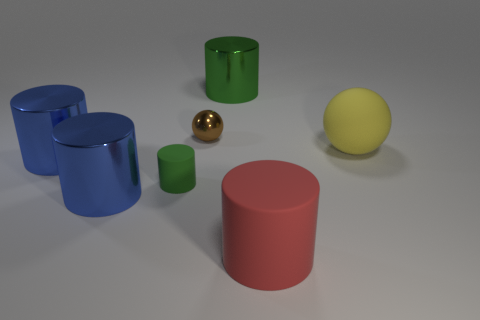The big object that is the same shape as the small brown object is what color?
Ensure brevity in your answer.  Yellow. Are there the same number of big green objects and yellow metallic blocks?
Make the answer very short. No. How many tiny green things are the same shape as the small brown object?
Your answer should be very brief. 0. There is a large cylinder that is the same color as the small cylinder; what is its material?
Make the answer very short. Metal. How many red matte cylinders are there?
Provide a succinct answer. 1. Are there any brown balls that have the same material as the yellow ball?
Ensure brevity in your answer.  No. The shiny cylinder that is the same color as the tiny rubber object is what size?
Give a very brief answer. Large. There is a green object to the right of the tiny sphere; does it have the same size as the blue metal cylinder that is behind the green matte cylinder?
Provide a succinct answer. Yes. How big is the ball in front of the small brown metallic object?
Keep it short and to the point. Large. Are there any other small matte cylinders that have the same color as the small cylinder?
Make the answer very short. No. 